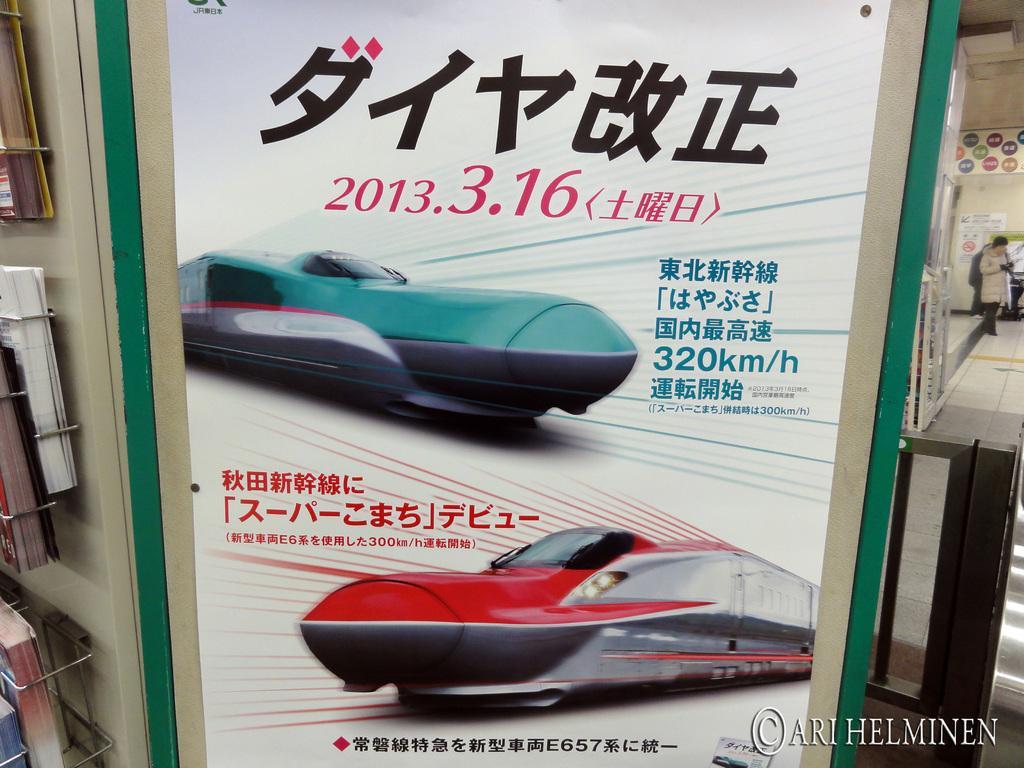How would you summarize this image in a sentence or two? In this image there is a poster attached to the wall. On the poster there are a few images and text on it. On the left side of the image there are books arranged in a rack. On the right side of the image there is a person walking on the floor and in the background there is a wall with some posters attached to it and there is a railing. At the bottom of the image there is some text. 